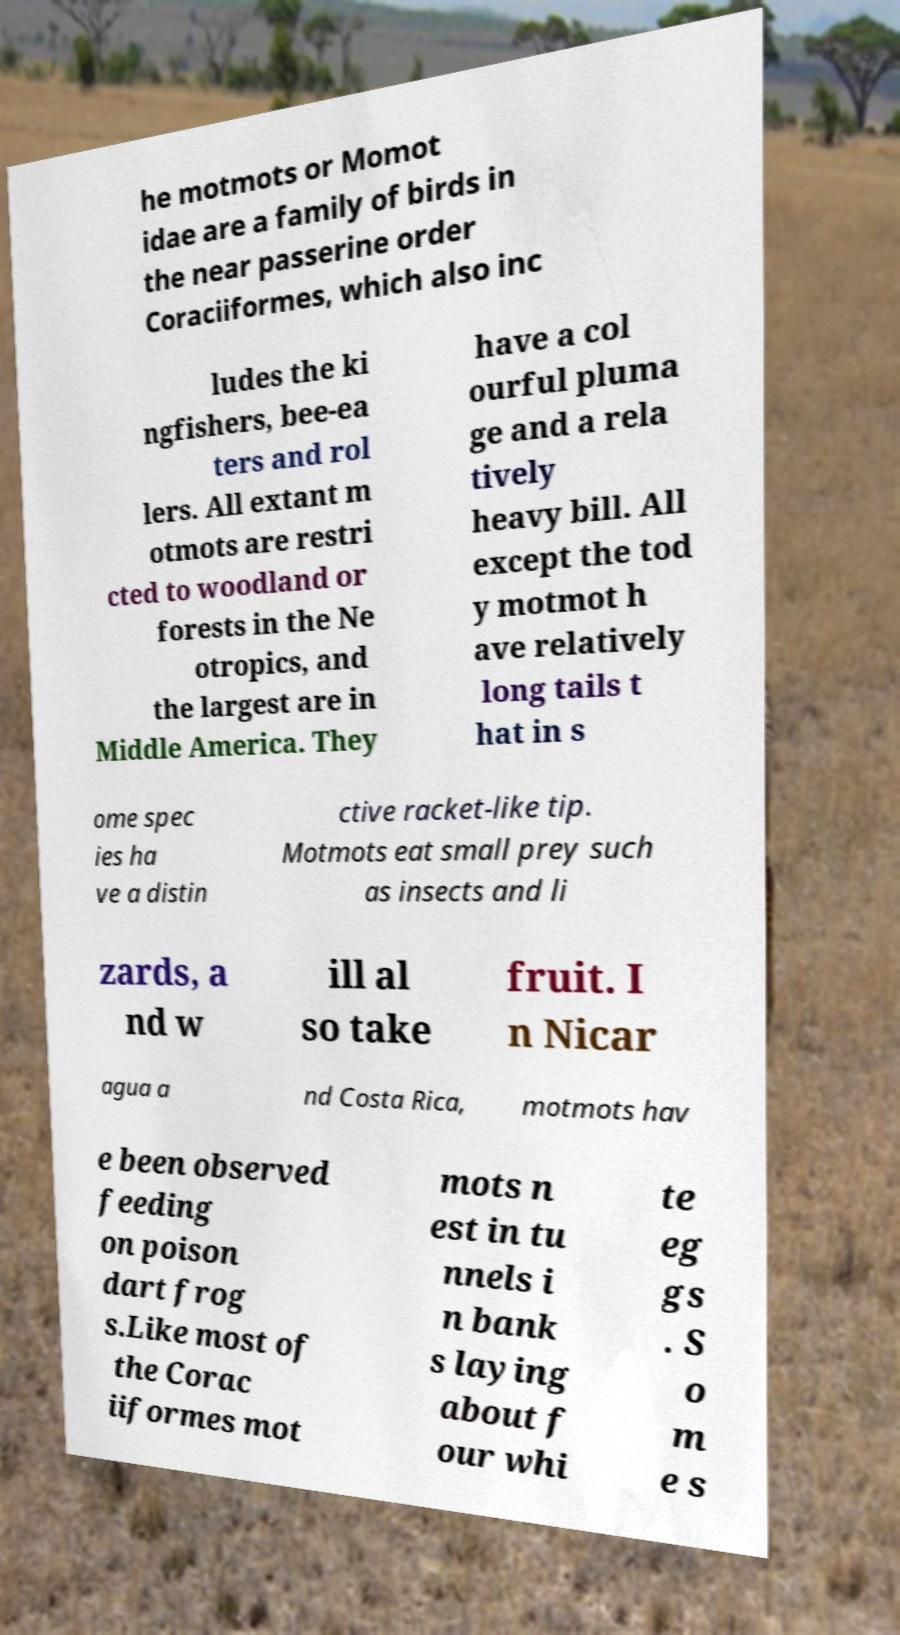What messages or text are displayed in this image? I need them in a readable, typed format. he motmots or Momot idae are a family of birds in the near passerine order Coraciiformes, which also inc ludes the ki ngfishers, bee-ea ters and rol lers. All extant m otmots are restri cted to woodland or forests in the Ne otropics, and the largest are in Middle America. They have a col ourful pluma ge and a rela tively heavy bill. All except the tod y motmot h ave relatively long tails t hat in s ome spec ies ha ve a distin ctive racket-like tip. Motmots eat small prey such as insects and li zards, a nd w ill al so take fruit. I n Nicar agua a nd Costa Rica, motmots hav e been observed feeding on poison dart frog s.Like most of the Corac iiformes mot mots n est in tu nnels i n bank s laying about f our whi te eg gs . S o m e s 